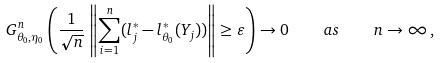Convert formula to latex. <formula><loc_0><loc_0><loc_500><loc_500>G ^ { n } _ { \theta _ { 0 } , \eta _ { 0 } } \left ( \frac { 1 } { \sqrt { n } } \, \left \| \sum _ { i = 1 } ^ { n } ( l _ { j } ^ { \ast } - l ^ { \ast } _ { \theta _ { 0 } } ( Y _ { j } ) ) \right \| \geq \varepsilon \right ) \rightarrow 0 \quad a s \quad n \rightarrow \infty \, ,</formula> 